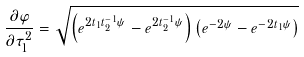Convert formula to latex. <formula><loc_0><loc_0><loc_500><loc_500>\frac { \partial \varphi } { \partial \tau _ { 1 } ^ { 2 } } = \sqrt { \left ( e ^ { 2 t _ { 1 } t _ { 2 } ^ { - 1 } \psi } - e ^ { 2 t _ { 2 } ^ { - 1 } \psi } \right ) \left ( e ^ { - 2 \psi } - e ^ { - 2 t _ { 1 } \psi } \right ) }</formula> 